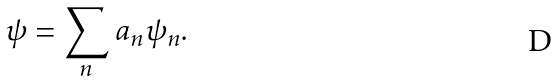Convert formula to latex. <formula><loc_0><loc_0><loc_500><loc_500>\psi = \sum _ { n } \, a _ { n } \psi _ { n } .</formula> 